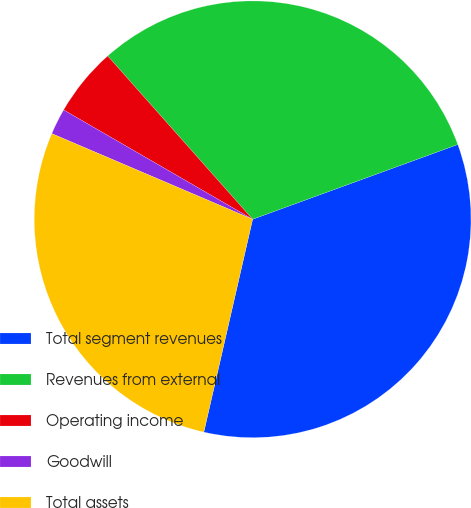<chart> <loc_0><loc_0><loc_500><loc_500><pie_chart><fcel>Total segment revenues<fcel>Revenues from external<fcel>Operating income<fcel>Goodwill<fcel>Total assets<nl><fcel>34.15%<fcel>30.99%<fcel>5.1%<fcel>1.93%<fcel>27.83%<nl></chart> 